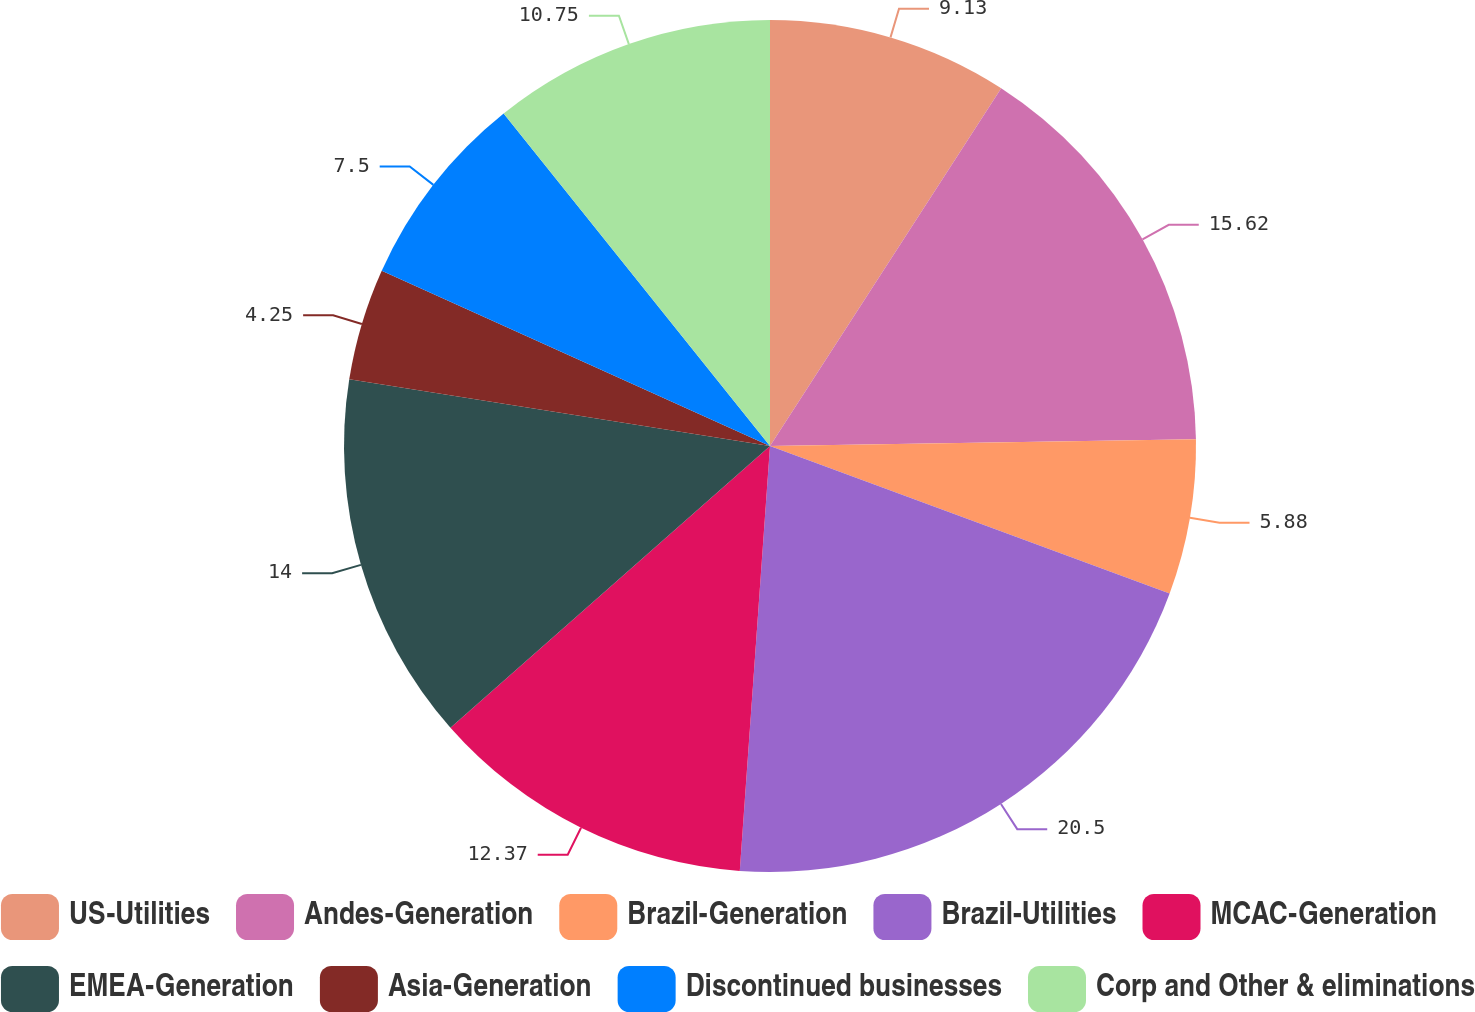Convert chart to OTSL. <chart><loc_0><loc_0><loc_500><loc_500><pie_chart><fcel>US-Utilities<fcel>Andes-Generation<fcel>Brazil-Generation<fcel>Brazil-Utilities<fcel>MCAC-Generation<fcel>EMEA-Generation<fcel>Asia-Generation<fcel>Discontinued businesses<fcel>Corp and Other & eliminations<nl><fcel>9.13%<fcel>15.62%<fcel>5.88%<fcel>20.5%<fcel>12.37%<fcel>14.0%<fcel>4.25%<fcel>7.5%<fcel>10.75%<nl></chart> 